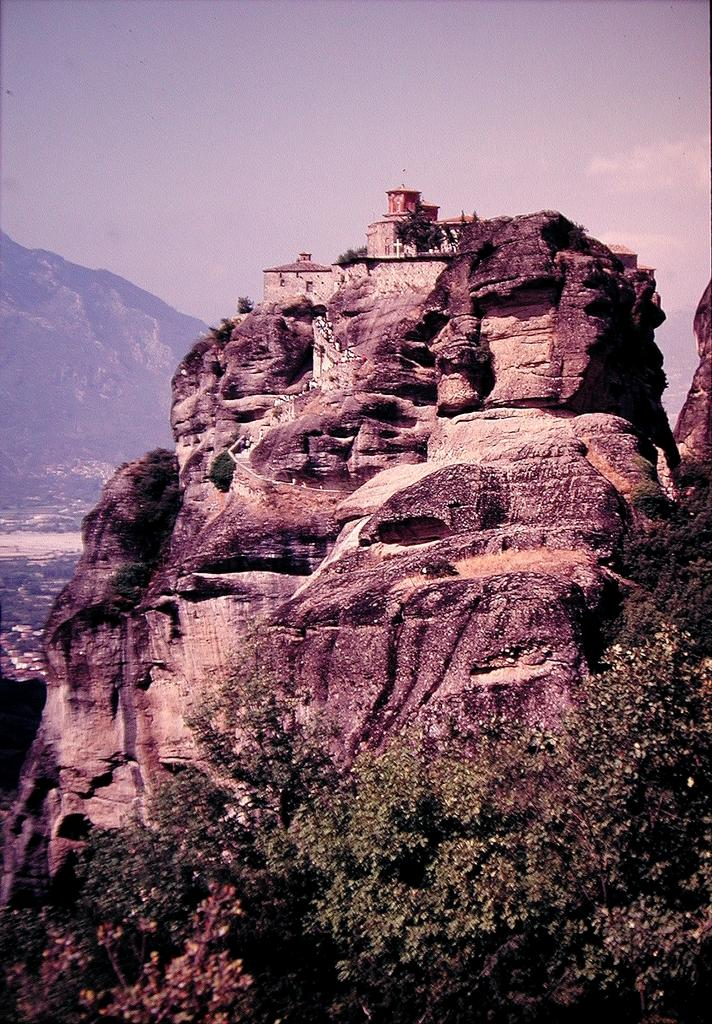What type of natural environment is depicted in the image? The image features many trees and hills, indicating a natural environment. How many houses can be seen in the image? There are few houses in the image. What is the condition of the sky in the image? The sky is blue and cloudy in the image. How many geese are flying over the hills in the image? There are no geese present in the image. What is the desire of the trees in the image? Trees do not have desires, as they are inanimate objects. 